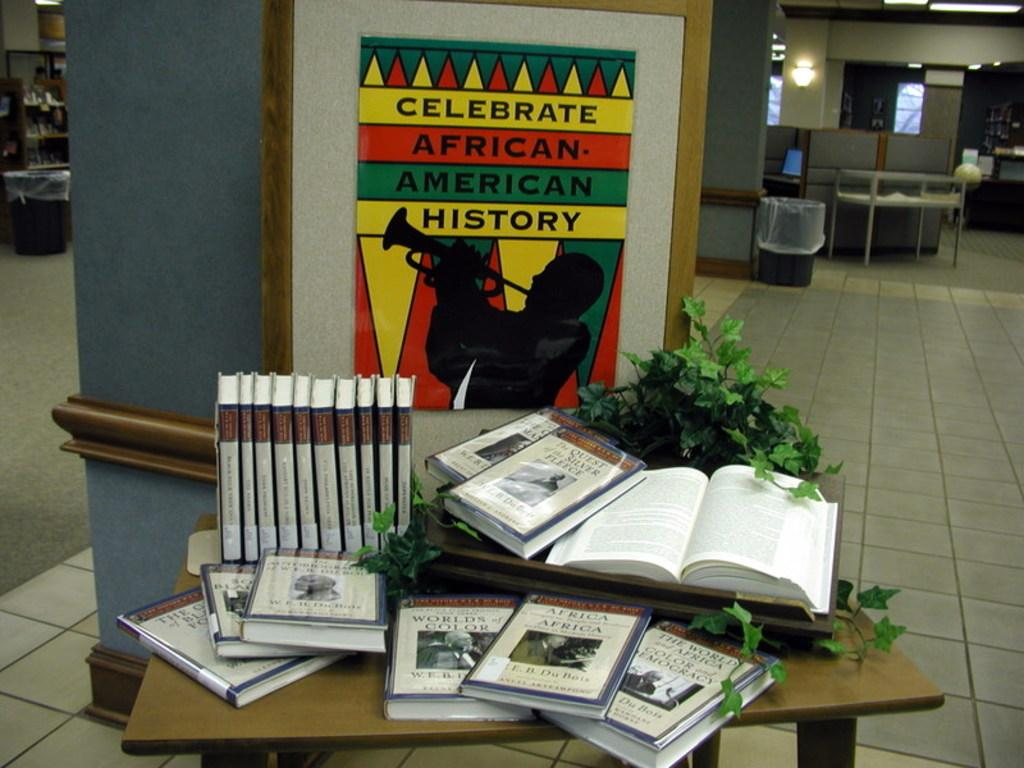Provide a one-sentence caption for the provided image. A poster about celebrating African-American history is hanging on the wall in a library. 